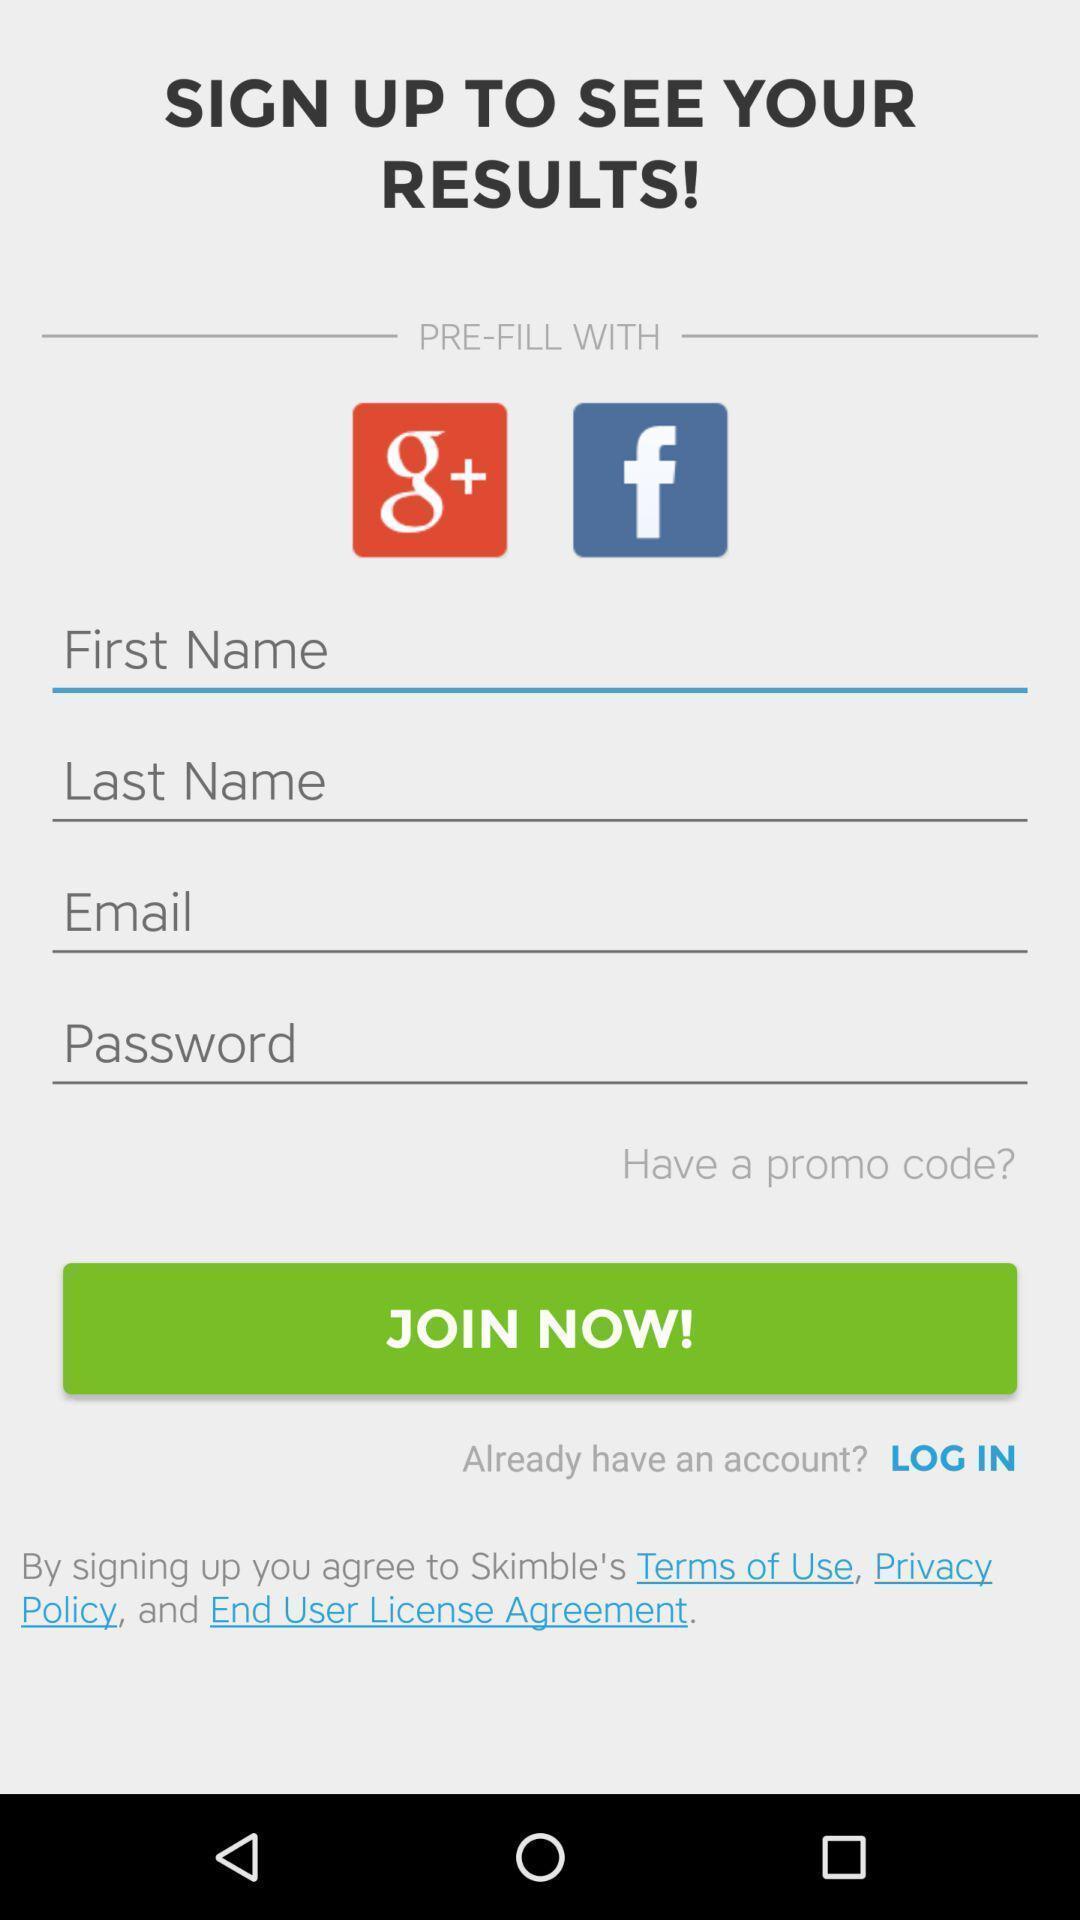Describe the key features of this screenshot. Sign up page for the application with entry details. 